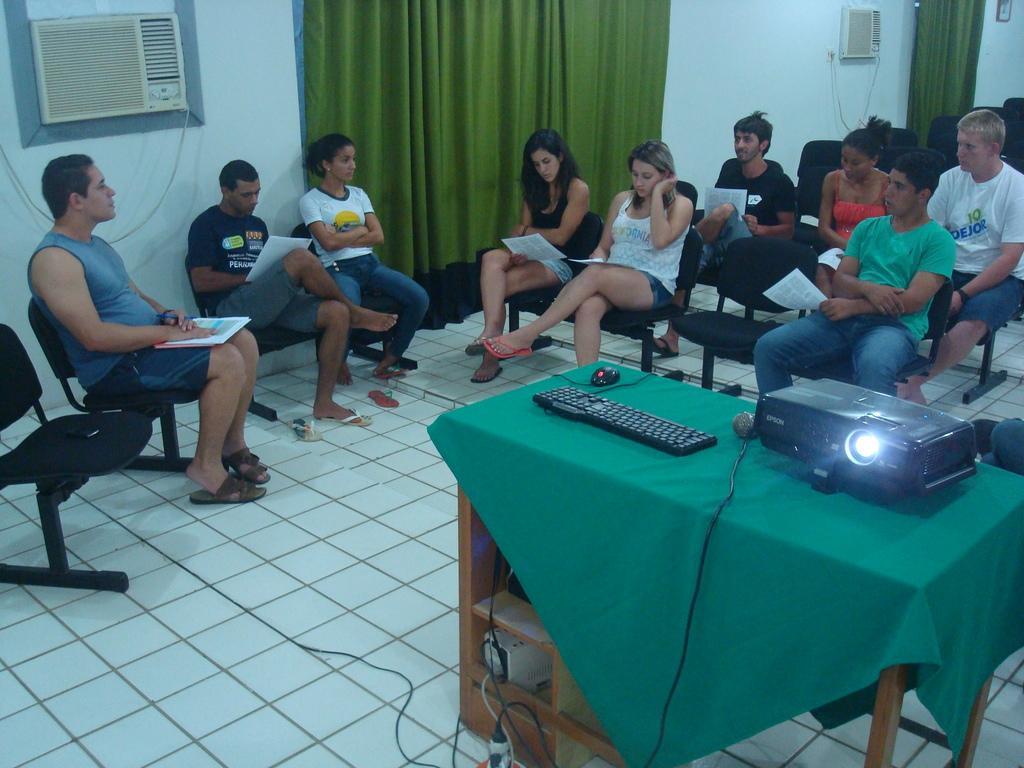Can you describe this image briefly? In this picture they are some people sitting here and as a projector on the table 